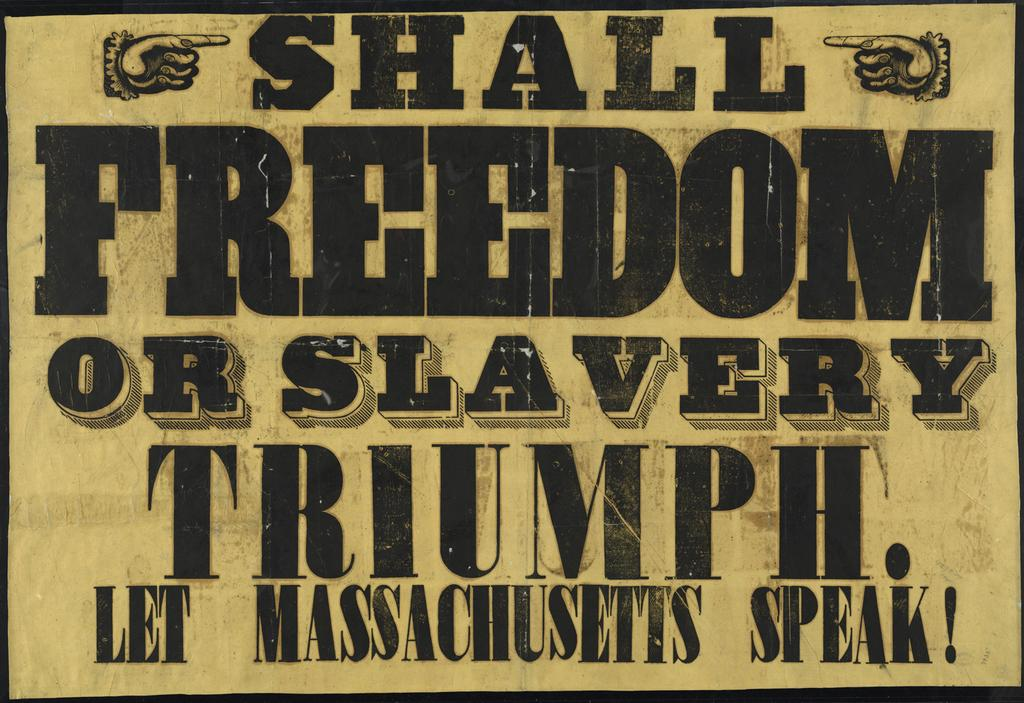<image>
Write a terse but informative summary of the picture. A yellow sign with hands pointing to the statement, shall freedom or slavery triumph. Let Massachusetts speak. 